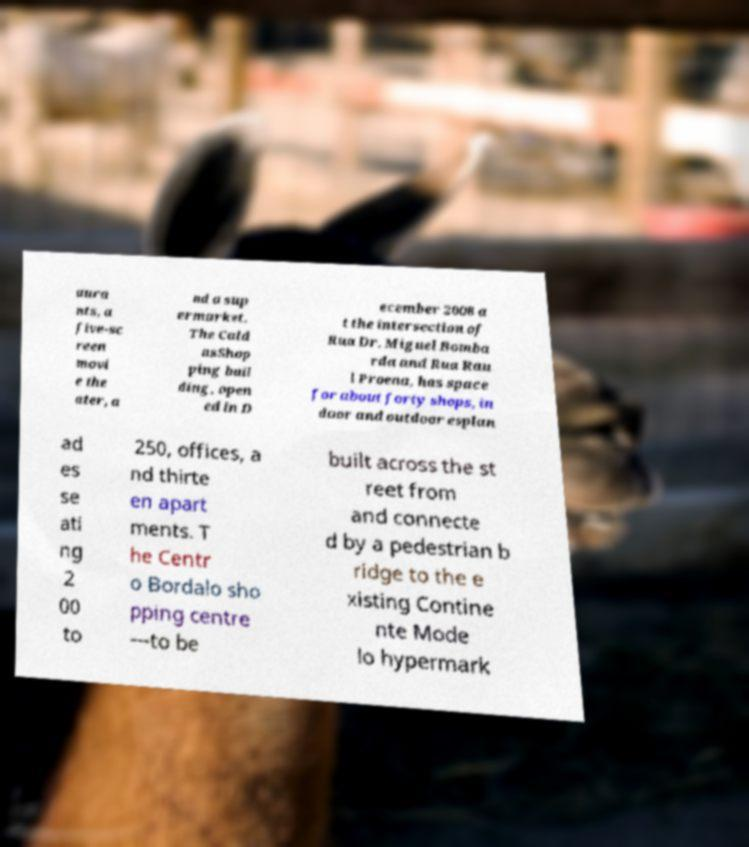Could you assist in decoding the text presented in this image and type it out clearly? aura nts, a five-sc reen movi e the ater, a nd a sup ermarket. The Cald asShop ping buil ding, open ed in D ecember 2008 a t the intersection of Rua Dr. Miguel Bomba rda and Rua Rau l Proena, has space for about forty shops, in door and outdoor esplan ad es se ati ng 2 00 to 250, offices, a nd thirte en apart ments. T he Centr o Bordalo sho pping centre —to be built across the st reet from and connecte d by a pedestrian b ridge to the e xisting Contine nte Mode lo hypermark 